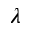Convert formula to latex. <formula><loc_0><loc_0><loc_500><loc_500>\lambda</formula> 